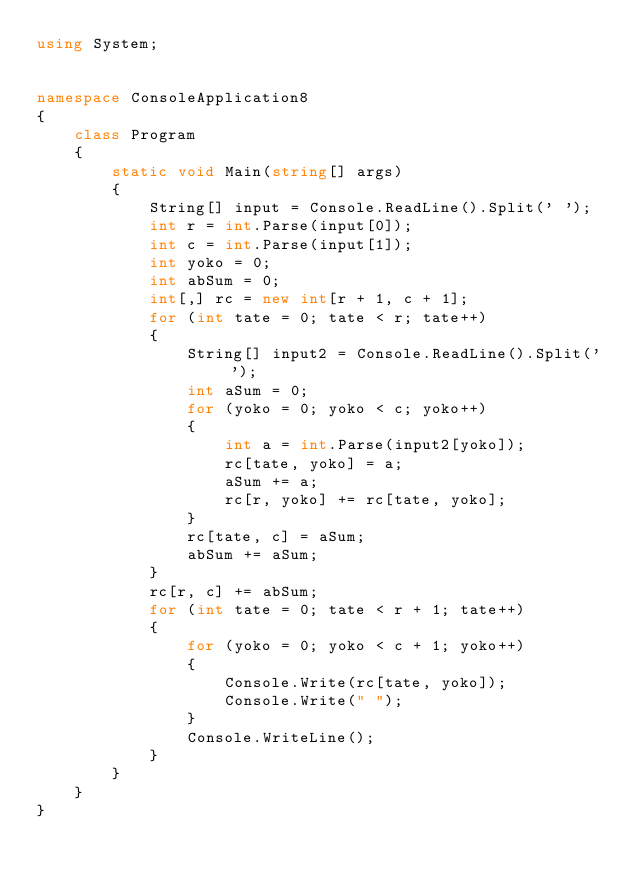Convert code to text. <code><loc_0><loc_0><loc_500><loc_500><_C#_>using System;


namespace ConsoleApplication8
{
    class Program
    {
        static void Main(string[] args)
        {
            String[] input = Console.ReadLine().Split(' ');
            int r = int.Parse(input[0]);
            int c = int.Parse(input[1]);
            int yoko = 0;
            int abSum = 0;
            int[,] rc = new int[r + 1, c + 1];
            for (int tate = 0; tate < r; tate++)
            {
                String[] input2 = Console.ReadLine().Split(' ');
                int aSum = 0;
                for (yoko = 0; yoko < c; yoko++)
                {
                    int a = int.Parse(input2[yoko]);
                    rc[tate, yoko] = a;
                    aSum += a;
                    rc[r, yoko] += rc[tate, yoko];
                }
                rc[tate, c] = aSum;
                abSum += aSum;
            }
            rc[r, c] += abSum;
            for (int tate = 0; tate < r + 1; tate++)
            {
                for (yoko = 0; yoko < c + 1; yoko++)
                {
                    Console.Write(rc[tate, yoko]);
                    Console.Write(" ");
                }
                Console.WriteLine();
            }
        }
    }
}</code> 